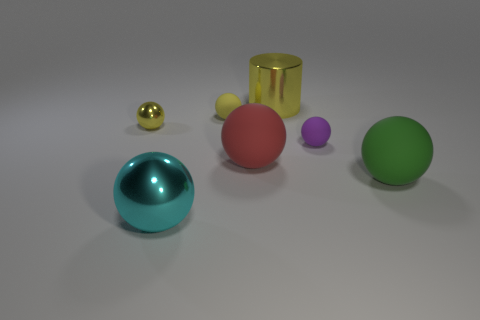Subtract 3 spheres. How many spheres are left? 3 Subtract all green spheres. How many spheres are left? 5 Subtract all big red spheres. How many spheres are left? 5 Subtract all cyan spheres. Subtract all red cylinders. How many spheres are left? 5 Add 3 red matte balls. How many objects exist? 10 Subtract all cylinders. How many objects are left? 6 Subtract all yellow shiny cylinders. Subtract all yellow rubber spheres. How many objects are left? 5 Add 6 cylinders. How many cylinders are left? 7 Add 7 tiny metal balls. How many tiny metal balls exist? 8 Subtract 0 blue cylinders. How many objects are left? 7 